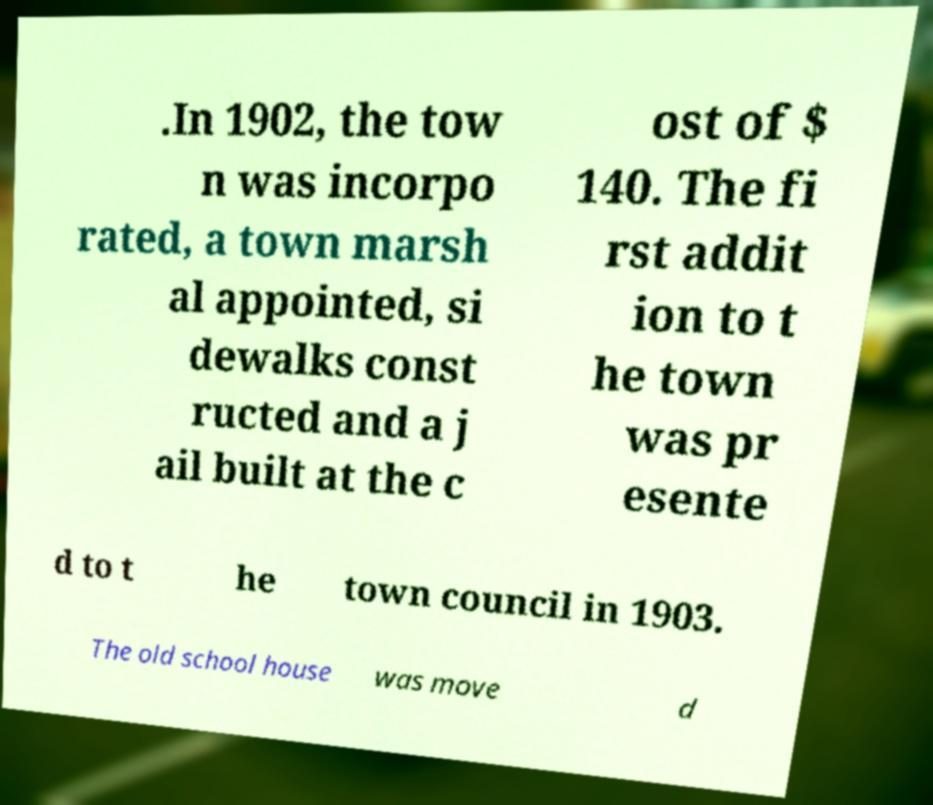For documentation purposes, I need the text within this image transcribed. Could you provide that? .In 1902, the tow n was incorpo rated, a town marsh al appointed, si dewalks const ructed and a j ail built at the c ost of $ 140. The fi rst addit ion to t he town was pr esente d to t he town council in 1903. The old school house was move d 